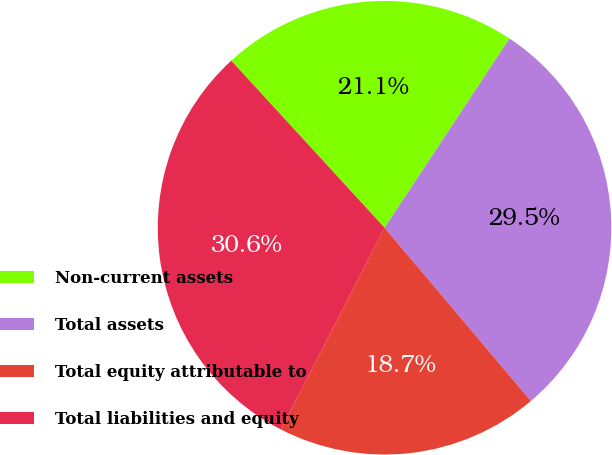Convert chart to OTSL. <chart><loc_0><loc_0><loc_500><loc_500><pie_chart><fcel>Non-current assets<fcel>Total assets<fcel>Total equity attributable to<fcel>Total liabilities and equity<nl><fcel>21.1%<fcel>29.55%<fcel>18.72%<fcel>30.63%<nl></chart> 